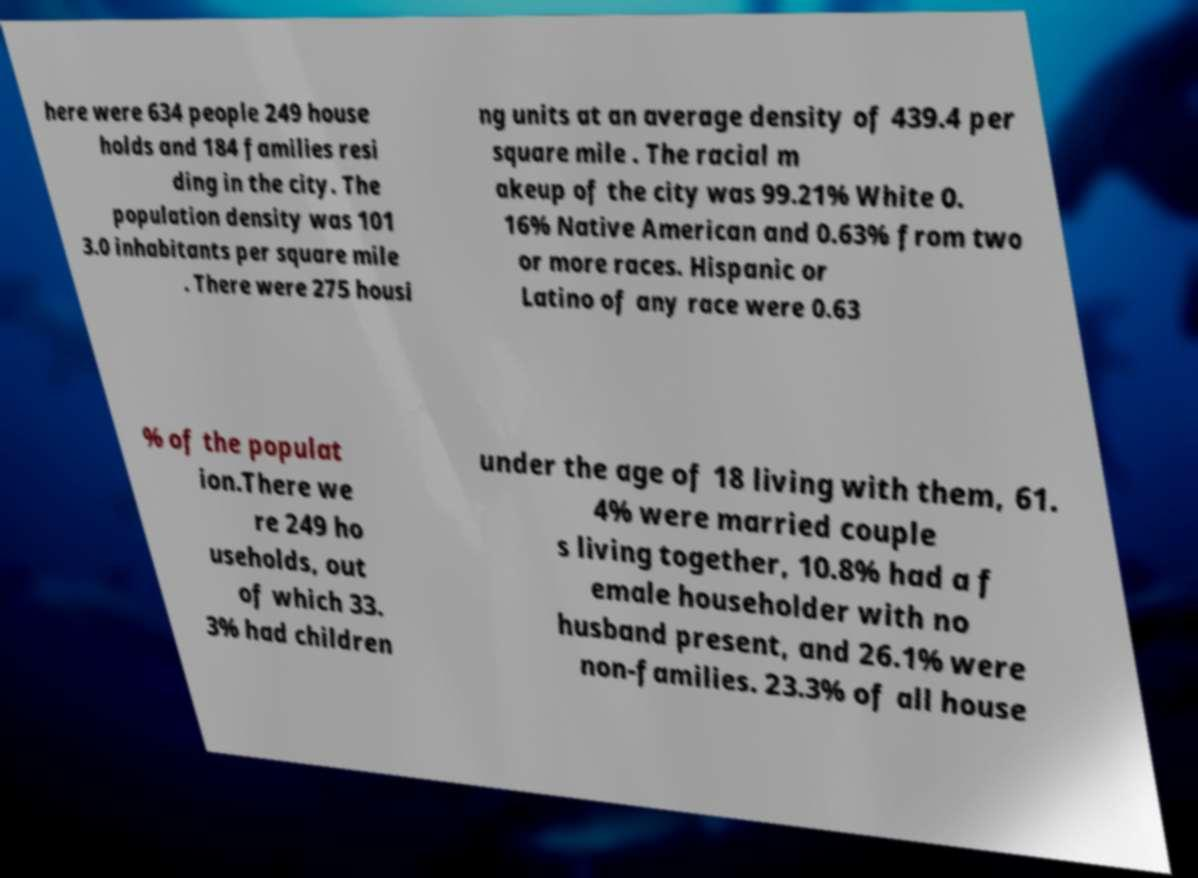Please read and relay the text visible in this image. What does it say? here were 634 people 249 house holds and 184 families resi ding in the city. The population density was 101 3.0 inhabitants per square mile . There were 275 housi ng units at an average density of 439.4 per square mile . The racial m akeup of the city was 99.21% White 0. 16% Native American and 0.63% from two or more races. Hispanic or Latino of any race were 0.63 % of the populat ion.There we re 249 ho useholds, out of which 33. 3% had children under the age of 18 living with them, 61. 4% were married couple s living together, 10.8% had a f emale householder with no husband present, and 26.1% were non-families. 23.3% of all house 